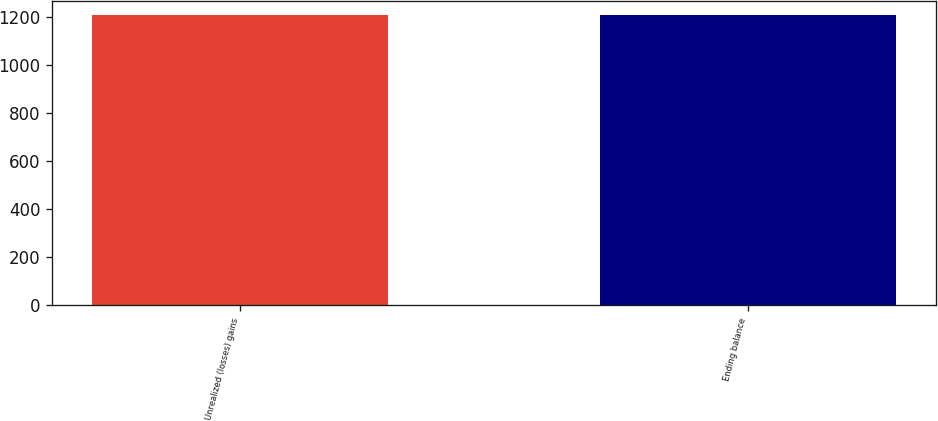<chart> <loc_0><loc_0><loc_500><loc_500><bar_chart><fcel>Unrealized (losses) gains<fcel>Ending balance<nl><fcel>1205<fcel>1205.1<nl></chart> 